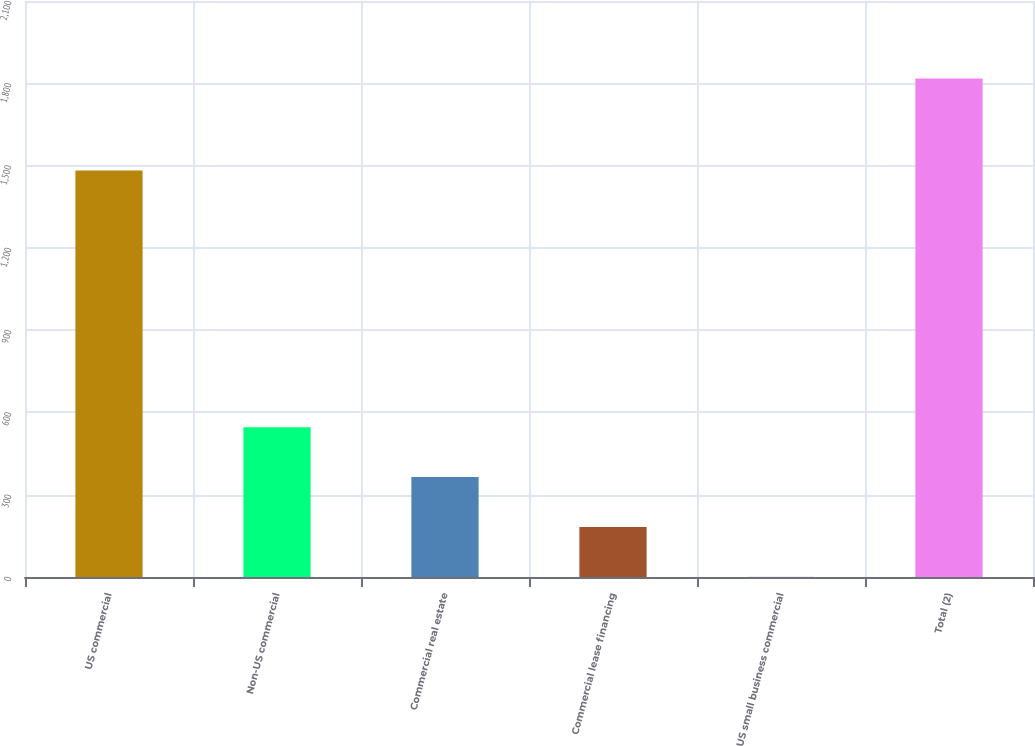<chart> <loc_0><loc_0><loc_500><loc_500><bar_chart><fcel>US commercial<fcel>Non-US commercial<fcel>Commercial real estate<fcel>Commercial lease financing<fcel>US small business commercial<fcel>Total (2)<nl><fcel>1482<fcel>545.8<fcel>364.2<fcel>182.6<fcel>1<fcel>1817<nl></chart> 